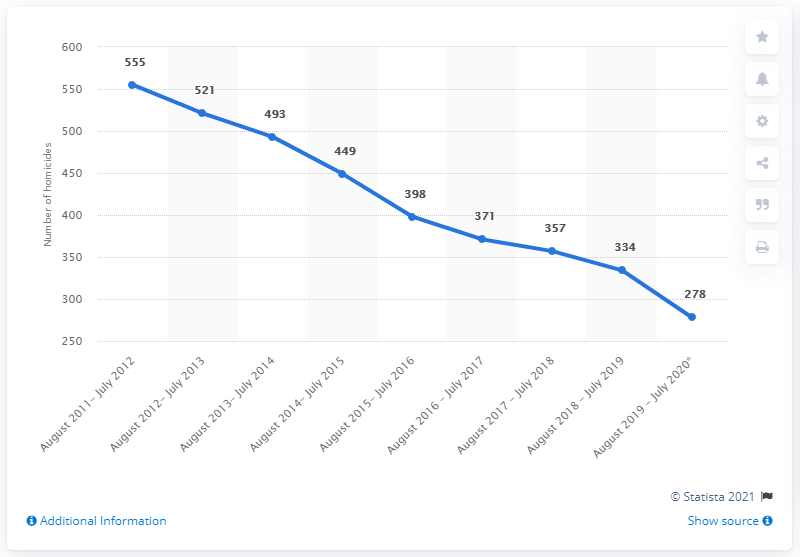Give some essential details in this illustration. In the period between August 2019 and July 2020, there were 278 homicides committed. 